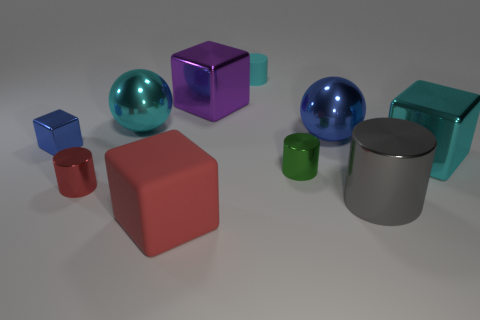Subtract all rubber cylinders. How many cylinders are left? 3 Subtract all blue blocks. How many blocks are left? 3 Subtract all blocks. How many objects are left? 6 Subtract 4 cylinders. How many cylinders are left? 0 Subtract all blue metal balls. Subtract all big cylinders. How many objects are left? 8 Add 2 red cubes. How many red cubes are left? 3 Add 2 tiny cyan matte cylinders. How many tiny cyan matte cylinders exist? 3 Subtract 1 green cylinders. How many objects are left? 9 Subtract all blue cubes. Subtract all red cylinders. How many cubes are left? 3 Subtract all brown cubes. How many cyan balls are left? 1 